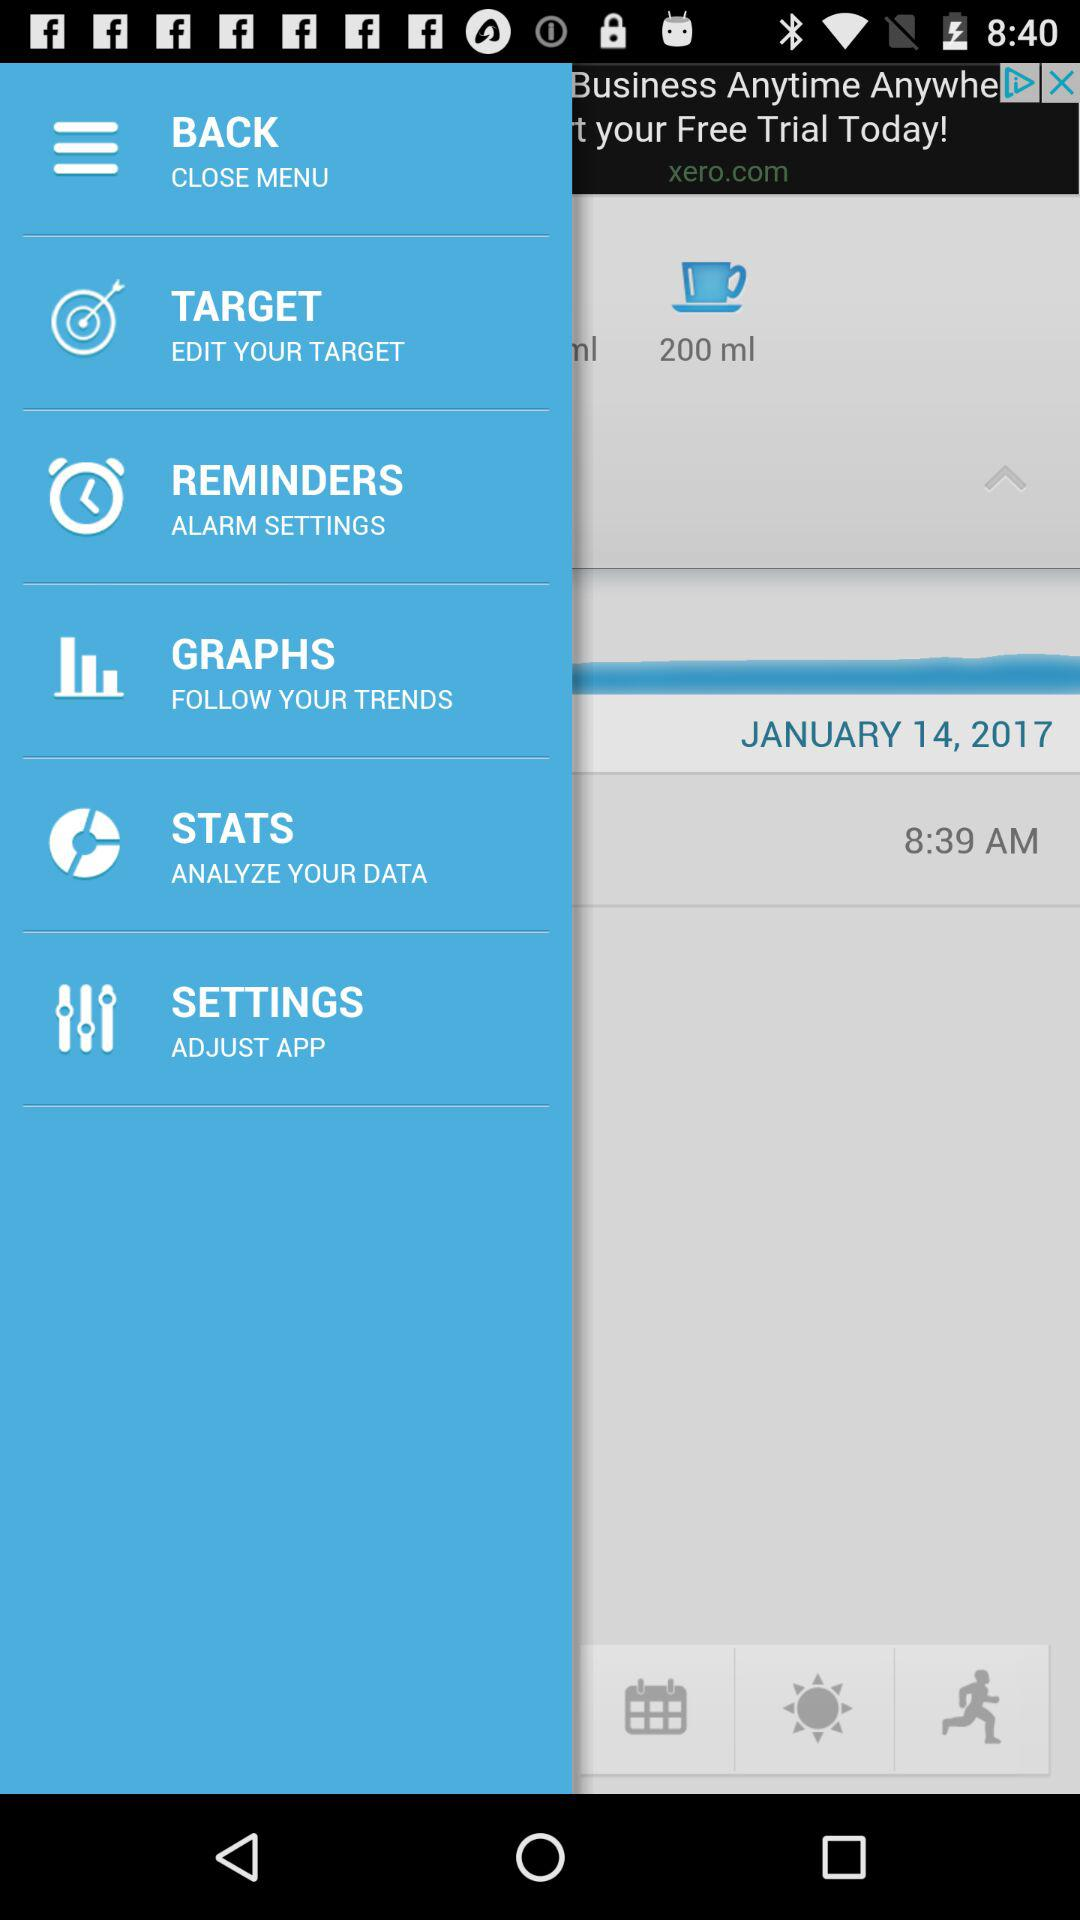What is the time? The time is 8:39 AM. 